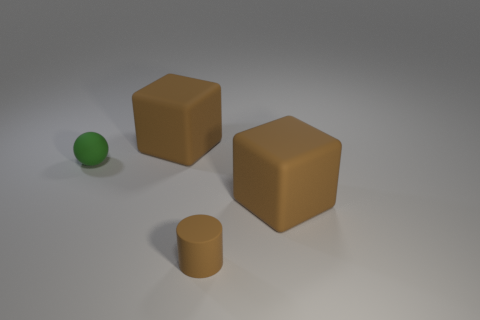How would you describe the lighting in this scene? The lighting in the image is soft and diffused, likely coming from an overhead source. It creates gentle shadows to the right of the objects, indicating a light source positioned to the upper left. 